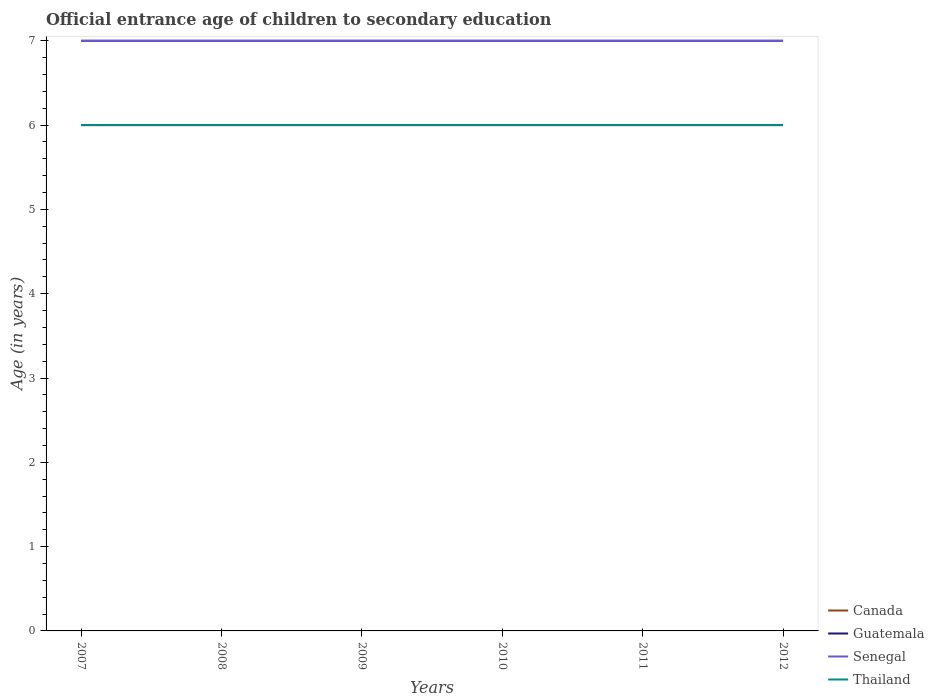Does the line corresponding to Senegal intersect with the line corresponding to Guatemala?
Your answer should be very brief. Yes. Is the number of lines equal to the number of legend labels?
Give a very brief answer. Yes. Across all years, what is the maximum secondary school starting age of children in Senegal?
Keep it short and to the point. 7. In which year was the secondary school starting age of children in Senegal maximum?
Offer a terse response. 2007. What is the difference between the highest and the second highest secondary school starting age of children in Thailand?
Make the answer very short. 0. What is the difference between the highest and the lowest secondary school starting age of children in Guatemala?
Offer a terse response. 0. Is the secondary school starting age of children in Thailand strictly greater than the secondary school starting age of children in Guatemala over the years?
Provide a succinct answer. Yes. How many lines are there?
Offer a terse response. 4. How many years are there in the graph?
Give a very brief answer. 6. Are the values on the major ticks of Y-axis written in scientific E-notation?
Provide a short and direct response. No. Does the graph contain any zero values?
Provide a succinct answer. No. Does the graph contain grids?
Your answer should be very brief. No. How many legend labels are there?
Your answer should be very brief. 4. How are the legend labels stacked?
Provide a short and direct response. Vertical. What is the title of the graph?
Provide a short and direct response. Official entrance age of children to secondary education. Does "Croatia" appear as one of the legend labels in the graph?
Ensure brevity in your answer.  No. What is the label or title of the X-axis?
Offer a terse response. Years. What is the label or title of the Y-axis?
Offer a terse response. Age (in years). What is the Age (in years) in Canada in 2007?
Your answer should be very brief. 6. What is the Age (in years) in Guatemala in 2007?
Your response must be concise. 7. What is the Age (in years) of Thailand in 2007?
Your answer should be compact. 6. What is the Age (in years) in Canada in 2008?
Keep it short and to the point. 6. What is the Age (in years) in Guatemala in 2008?
Your response must be concise. 7. What is the Age (in years) of Thailand in 2008?
Your response must be concise. 6. What is the Age (in years) in Canada in 2009?
Your answer should be very brief. 6. What is the Age (in years) in Guatemala in 2009?
Keep it short and to the point. 7. What is the Age (in years) in Senegal in 2009?
Offer a very short reply. 7. What is the Age (in years) of Canada in 2010?
Your answer should be very brief. 6. What is the Age (in years) of Guatemala in 2010?
Provide a succinct answer. 7. What is the Age (in years) of Senegal in 2011?
Your answer should be compact. 7. What is the Age (in years) in Thailand in 2011?
Your answer should be very brief. 6. Across all years, what is the maximum Age (in years) of Guatemala?
Ensure brevity in your answer.  7. Across all years, what is the maximum Age (in years) in Thailand?
Keep it short and to the point. 6. Across all years, what is the minimum Age (in years) in Guatemala?
Provide a succinct answer. 7. Across all years, what is the minimum Age (in years) in Senegal?
Offer a terse response. 7. Across all years, what is the minimum Age (in years) in Thailand?
Offer a very short reply. 6. What is the total Age (in years) in Canada in the graph?
Provide a succinct answer. 36. What is the total Age (in years) in Guatemala in the graph?
Ensure brevity in your answer.  42. What is the total Age (in years) in Senegal in the graph?
Your response must be concise. 42. What is the difference between the Age (in years) of Canada in 2007 and that in 2008?
Make the answer very short. 0. What is the difference between the Age (in years) in Thailand in 2007 and that in 2008?
Make the answer very short. 0. What is the difference between the Age (in years) in Guatemala in 2007 and that in 2009?
Your answer should be compact. 0. What is the difference between the Age (in years) of Senegal in 2007 and that in 2009?
Offer a very short reply. 0. What is the difference between the Age (in years) in Thailand in 2007 and that in 2009?
Your response must be concise. 0. What is the difference between the Age (in years) of Canada in 2007 and that in 2010?
Your answer should be very brief. 0. What is the difference between the Age (in years) of Thailand in 2007 and that in 2010?
Offer a terse response. 0. What is the difference between the Age (in years) of Senegal in 2007 and that in 2011?
Provide a succinct answer. 0. What is the difference between the Age (in years) in Thailand in 2007 and that in 2011?
Give a very brief answer. 0. What is the difference between the Age (in years) of Canada in 2007 and that in 2012?
Your answer should be very brief. 0. What is the difference between the Age (in years) of Guatemala in 2007 and that in 2012?
Your answer should be very brief. 0. What is the difference between the Age (in years) of Senegal in 2007 and that in 2012?
Your answer should be compact. 0. What is the difference between the Age (in years) of Thailand in 2007 and that in 2012?
Provide a short and direct response. 0. What is the difference between the Age (in years) of Canada in 2008 and that in 2009?
Provide a succinct answer. 0. What is the difference between the Age (in years) in Canada in 2008 and that in 2010?
Your answer should be compact. 0. What is the difference between the Age (in years) of Senegal in 2008 and that in 2010?
Offer a very short reply. 0. What is the difference between the Age (in years) in Thailand in 2008 and that in 2010?
Make the answer very short. 0. What is the difference between the Age (in years) in Canada in 2008 and that in 2011?
Make the answer very short. 0. What is the difference between the Age (in years) in Guatemala in 2008 and that in 2011?
Your answer should be compact. 0. What is the difference between the Age (in years) of Senegal in 2008 and that in 2011?
Offer a terse response. 0. What is the difference between the Age (in years) in Canada in 2008 and that in 2012?
Ensure brevity in your answer.  0. What is the difference between the Age (in years) in Guatemala in 2008 and that in 2012?
Give a very brief answer. 0. What is the difference between the Age (in years) of Senegal in 2008 and that in 2012?
Ensure brevity in your answer.  0. What is the difference between the Age (in years) in Thailand in 2008 and that in 2012?
Make the answer very short. 0. What is the difference between the Age (in years) in Guatemala in 2009 and that in 2010?
Provide a succinct answer. 0. What is the difference between the Age (in years) in Senegal in 2009 and that in 2010?
Make the answer very short. 0. What is the difference between the Age (in years) in Senegal in 2009 and that in 2011?
Make the answer very short. 0. What is the difference between the Age (in years) in Thailand in 2009 and that in 2011?
Keep it short and to the point. 0. What is the difference between the Age (in years) in Senegal in 2009 and that in 2012?
Your answer should be compact. 0. What is the difference between the Age (in years) in Canada in 2010 and that in 2011?
Make the answer very short. 0. What is the difference between the Age (in years) in Guatemala in 2010 and that in 2011?
Give a very brief answer. 0. What is the difference between the Age (in years) of Thailand in 2010 and that in 2011?
Give a very brief answer. 0. What is the difference between the Age (in years) in Thailand in 2010 and that in 2012?
Offer a terse response. 0. What is the difference between the Age (in years) of Canada in 2011 and that in 2012?
Provide a succinct answer. 0. What is the difference between the Age (in years) of Senegal in 2011 and that in 2012?
Ensure brevity in your answer.  0. What is the difference between the Age (in years) in Guatemala in 2007 and the Age (in years) in Thailand in 2008?
Keep it short and to the point. 1. What is the difference between the Age (in years) of Senegal in 2007 and the Age (in years) of Thailand in 2008?
Provide a succinct answer. 1. What is the difference between the Age (in years) in Canada in 2007 and the Age (in years) in Guatemala in 2009?
Keep it short and to the point. -1. What is the difference between the Age (in years) in Canada in 2007 and the Age (in years) in Senegal in 2009?
Ensure brevity in your answer.  -1. What is the difference between the Age (in years) of Canada in 2007 and the Age (in years) of Thailand in 2009?
Your response must be concise. 0. What is the difference between the Age (in years) in Senegal in 2007 and the Age (in years) in Thailand in 2009?
Ensure brevity in your answer.  1. What is the difference between the Age (in years) in Canada in 2007 and the Age (in years) in Senegal in 2010?
Give a very brief answer. -1. What is the difference between the Age (in years) of Canada in 2007 and the Age (in years) of Thailand in 2010?
Keep it short and to the point. 0. What is the difference between the Age (in years) in Guatemala in 2007 and the Age (in years) in Thailand in 2010?
Offer a terse response. 1. What is the difference between the Age (in years) in Canada in 2007 and the Age (in years) in Senegal in 2011?
Offer a very short reply. -1. What is the difference between the Age (in years) in Canada in 2007 and the Age (in years) in Thailand in 2011?
Your answer should be compact. 0. What is the difference between the Age (in years) in Senegal in 2007 and the Age (in years) in Thailand in 2011?
Provide a short and direct response. 1. What is the difference between the Age (in years) of Canada in 2007 and the Age (in years) of Guatemala in 2012?
Your answer should be very brief. -1. What is the difference between the Age (in years) in Canada in 2007 and the Age (in years) in Senegal in 2012?
Your answer should be very brief. -1. What is the difference between the Age (in years) of Canada in 2007 and the Age (in years) of Thailand in 2012?
Provide a succinct answer. 0. What is the difference between the Age (in years) in Senegal in 2007 and the Age (in years) in Thailand in 2012?
Your answer should be compact. 1. What is the difference between the Age (in years) in Guatemala in 2008 and the Age (in years) in Senegal in 2009?
Make the answer very short. 0. What is the difference between the Age (in years) of Guatemala in 2008 and the Age (in years) of Thailand in 2009?
Offer a terse response. 1. What is the difference between the Age (in years) of Canada in 2008 and the Age (in years) of Senegal in 2010?
Give a very brief answer. -1. What is the difference between the Age (in years) of Canada in 2008 and the Age (in years) of Thailand in 2010?
Ensure brevity in your answer.  0. What is the difference between the Age (in years) in Guatemala in 2008 and the Age (in years) in Senegal in 2010?
Ensure brevity in your answer.  0. What is the difference between the Age (in years) in Canada in 2008 and the Age (in years) in Guatemala in 2011?
Give a very brief answer. -1. What is the difference between the Age (in years) of Canada in 2008 and the Age (in years) of Senegal in 2011?
Ensure brevity in your answer.  -1. What is the difference between the Age (in years) of Senegal in 2008 and the Age (in years) of Thailand in 2011?
Keep it short and to the point. 1. What is the difference between the Age (in years) in Canada in 2008 and the Age (in years) in Thailand in 2012?
Your response must be concise. 0. What is the difference between the Age (in years) in Guatemala in 2008 and the Age (in years) in Senegal in 2012?
Make the answer very short. 0. What is the difference between the Age (in years) of Guatemala in 2008 and the Age (in years) of Thailand in 2012?
Ensure brevity in your answer.  1. What is the difference between the Age (in years) in Senegal in 2008 and the Age (in years) in Thailand in 2012?
Your response must be concise. 1. What is the difference between the Age (in years) of Canada in 2009 and the Age (in years) of Guatemala in 2010?
Keep it short and to the point. -1. What is the difference between the Age (in years) in Canada in 2009 and the Age (in years) in Thailand in 2010?
Ensure brevity in your answer.  0. What is the difference between the Age (in years) in Guatemala in 2009 and the Age (in years) in Thailand in 2010?
Make the answer very short. 1. What is the difference between the Age (in years) of Senegal in 2009 and the Age (in years) of Thailand in 2010?
Give a very brief answer. 1. What is the difference between the Age (in years) in Canada in 2009 and the Age (in years) in Guatemala in 2011?
Make the answer very short. -1. What is the difference between the Age (in years) of Guatemala in 2009 and the Age (in years) of Senegal in 2011?
Provide a short and direct response. 0. What is the difference between the Age (in years) in Canada in 2009 and the Age (in years) in Senegal in 2012?
Offer a very short reply. -1. What is the difference between the Age (in years) in Guatemala in 2009 and the Age (in years) in Senegal in 2012?
Your response must be concise. 0. What is the difference between the Age (in years) of Guatemala in 2009 and the Age (in years) of Thailand in 2012?
Provide a short and direct response. 1. What is the difference between the Age (in years) in Canada in 2010 and the Age (in years) in Senegal in 2011?
Your answer should be compact. -1. What is the difference between the Age (in years) of Canada in 2010 and the Age (in years) of Thailand in 2011?
Offer a terse response. 0. What is the difference between the Age (in years) in Guatemala in 2010 and the Age (in years) in Senegal in 2011?
Provide a succinct answer. 0. What is the difference between the Age (in years) in Canada in 2010 and the Age (in years) in Guatemala in 2012?
Your answer should be very brief. -1. What is the difference between the Age (in years) of Canada in 2010 and the Age (in years) of Senegal in 2012?
Make the answer very short. -1. What is the difference between the Age (in years) in Guatemala in 2010 and the Age (in years) in Thailand in 2012?
Your answer should be compact. 1. What is the difference between the Age (in years) of Senegal in 2010 and the Age (in years) of Thailand in 2012?
Your answer should be very brief. 1. What is the difference between the Age (in years) in Canada in 2011 and the Age (in years) in Guatemala in 2012?
Offer a very short reply. -1. What is the difference between the Age (in years) of Canada in 2011 and the Age (in years) of Senegal in 2012?
Provide a succinct answer. -1. What is the difference between the Age (in years) of Canada in 2011 and the Age (in years) of Thailand in 2012?
Keep it short and to the point. 0. What is the average Age (in years) of Canada per year?
Offer a terse response. 6. What is the average Age (in years) of Guatemala per year?
Offer a terse response. 7. In the year 2007, what is the difference between the Age (in years) in Canada and Age (in years) in Guatemala?
Make the answer very short. -1. In the year 2007, what is the difference between the Age (in years) of Canada and Age (in years) of Senegal?
Keep it short and to the point. -1. In the year 2007, what is the difference between the Age (in years) of Canada and Age (in years) of Thailand?
Your answer should be compact. 0. In the year 2007, what is the difference between the Age (in years) in Guatemala and Age (in years) in Senegal?
Make the answer very short. 0. In the year 2007, what is the difference between the Age (in years) of Guatemala and Age (in years) of Thailand?
Provide a succinct answer. 1. In the year 2007, what is the difference between the Age (in years) of Senegal and Age (in years) of Thailand?
Your response must be concise. 1. In the year 2008, what is the difference between the Age (in years) of Canada and Age (in years) of Thailand?
Make the answer very short. 0. In the year 2009, what is the difference between the Age (in years) of Canada and Age (in years) of Guatemala?
Provide a short and direct response. -1. In the year 2009, what is the difference between the Age (in years) in Canada and Age (in years) in Senegal?
Keep it short and to the point. -1. In the year 2009, what is the difference between the Age (in years) in Guatemala and Age (in years) in Senegal?
Your response must be concise. 0. In the year 2009, what is the difference between the Age (in years) in Guatemala and Age (in years) in Thailand?
Provide a short and direct response. 1. In the year 2010, what is the difference between the Age (in years) in Guatemala and Age (in years) in Thailand?
Your answer should be very brief. 1. In the year 2011, what is the difference between the Age (in years) in Canada and Age (in years) in Guatemala?
Make the answer very short. -1. In the year 2011, what is the difference between the Age (in years) in Canada and Age (in years) in Thailand?
Offer a terse response. 0. In the year 2011, what is the difference between the Age (in years) in Guatemala and Age (in years) in Senegal?
Offer a terse response. 0. In the year 2011, what is the difference between the Age (in years) in Guatemala and Age (in years) in Thailand?
Make the answer very short. 1. In the year 2011, what is the difference between the Age (in years) in Senegal and Age (in years) in Thailand?
Provide a short and direct response. 1. In the year 2012, what is the difference between the Age (in years) in Canada and Age (in years) in Guatemala?
Give a very brief answer. -1. In the year 2012, what is the difference between the Age (in years) in Guatemala and Age (in years) in Senegal?
Keep it short and to the point. 0. In the year 2012, what is the difference between the Age (in years) in Guatemala and Age (in years) in Thailand?
Keep it short and to the point. 1. What is the ratio of the Age (in years) of Guatemala in 2007 to that in 2008?
Give a very brief answer. 1. What is the ratio of the Age (in years) in Canada in 2007 to that in 2009?
Your answer should be compact. 1. What is the ratio of the Age (in years) in Senegal in 2007 to that in 2009?
Offer a very short reply. 1. What is the ratio of the Age (in years) of Canada in 2007 to that in 2010?
Your answer should be very brief. 1. What is the ratio of the Age (in years) in Guatemala in 2007 to that in 2010?
Ensure brevity in your answer.  1. What is the ratio of the Age (in years) of Senegal in 2007 to that in 2010?
Ensure brevity in your answer.  1. What is the ratio of the Age (in years) of Canada in 2007 to that in 2011?
Give a very brief answer. 1. What is the ratio of the Age (in years) of Guatemala in 2007 to that in 2011?
Ensure brevity in your answer.  1. What is the ratio of the Age (in years) of Senegal in 2007 to that in 2011?
Provide a short and direct response. 1. What is the ratio of the Age (in years) in Guatemala in 2007 to that in 2012?
Your response must be concise. 1. What is the ratio of the Age (in years) in Senegal in 2007 to that in 2012?
Your answer should be very brief. 1. What is the ratio of the Age (in years) in Thailand in 2007 to that in 2012?
Your answer should be very brief. 1. What is the ratio of the Age (in years) in Senegal in 2008 to that in 2009?
Provide a short and direct response. 1. What is the ratio of the Age (in years) of Thailand in 2008 to that in 2009?
Offer a very short reply. 1. What is the ratio of the Age (in years) in Canada in 2008 to that in 2010?
Your answer should be compact. 1. What is the ratio of the Age (in years) of Guatemala in 2008 to that in 2010?
Give a very brief answer. 1. What is the ratio of the Age (in years) in Canada in 2008 to that in 2011?
Ensure brevity in your answer.  1. What is the ratio of the Age (in years) in Senegal in 2008 to that in 2011?
Your answer should be very brief. 1. What is the ratio of the Age (in years) in Thailand in 2008 to that in 2011?
Ensure brevity in your answer.  1. What is the ratio of the Age (in years) in Canada in 2008 to that in 2012?
Your answer should be very brief. 1. What is the ratio of the Age (in years) in Guatemala in 2008 to that in 2012?
Offer a terse response. 1. What is the ratio of the Age (in years) of Thailand in 2009 to that in 2010?
Give a very brief answer. 1. What is the ratio of the Age (in years) in Guatemala in 2009 to that in 2011?
Keep it short and to the point. 1. What is the ratio of the Age (in years) of Senegal in 2009 to that in 2011?
Give a very brief answer. 1. What is the ratio of the Age (in years) of Thailand in 2009 to that in 2011?
Give a very brief answer. 1. What is the ratio of the Age (in years) of Canada in 2009 to that in 2012?
Your answer should be very brief. 1. What is the ratio of the Age (in years) of Guatemala in 2010 to that in 2011?
Give a very brief answer. 1. What is the ratio of the Age (in years) in Thailand in 2010 to that in 2011?
Your answer should be very brief. 1. What is the ratio of the Age (in years) of Canada in 2010 to that in 2012?
Offer a very short reply. 1. What is the ratio of the Age (in years) of Guatemala in 2010 to that in 2012?
Make the answer very short. 1. What is the ratio of the Age (in years) of Thailand in 2010 to that in 2012?
Keep it short and to the point. 1. What is the difference between the highest and the second highest Age (in years) in Guatemala?
Your answer should be compact. 0. What is the difference between the highest and the second highest Age (in years) in Senegal?
Give a very brief answer. 0. What is the difference between the highest and the second highest Age (in years) in Thailand?
Ensure brevity in your answer.  0. What is the difference between the highest and the lowest Age (in years) of Senegal?
Your answer should be compact. 0. 